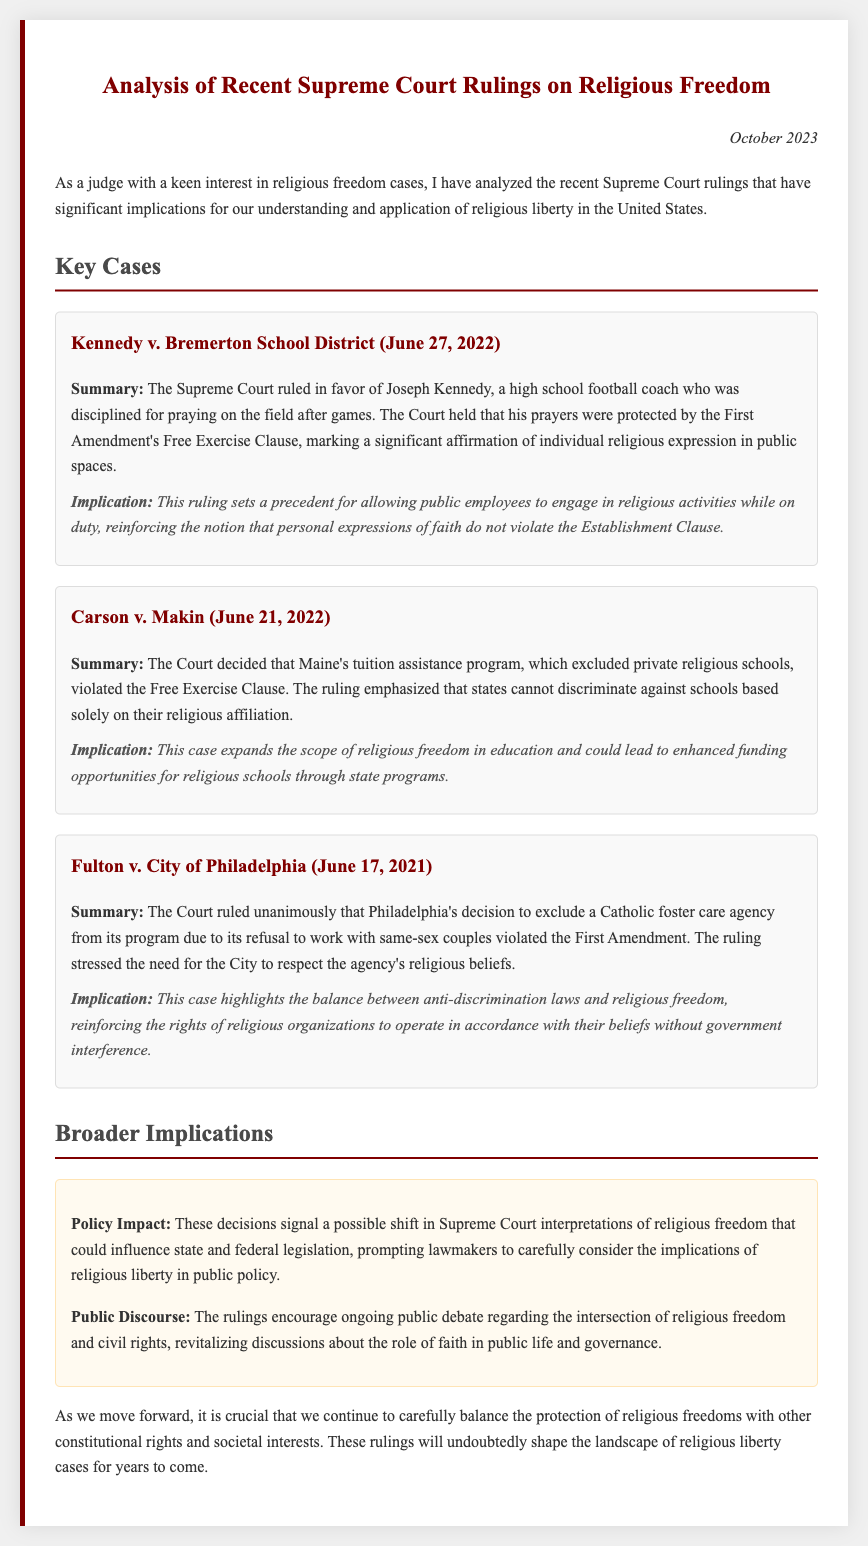What is the title of the memo? The title of the document summarizes its focus on Supreme Court rulings related to religious freedom.
Answer: Analysis of Recent Supreme Court Rulings on Religious Freedom When was the memo published? The publication date is noted in the document as a specific time frame for relevance.
Answer: October 2023 What is the outcome of the case Kennedy v. Bremerton School District? The document describes the ruling in favor of Joseph Kennedy regarding his right to pray on the field.
Answer: The Court ruled in favor of Joseph Kennedy What did the Court decide in Carson v. Makin? This question inquires about the specific ruling provided in the memo regarding Maine's tuition assistance program.
Answer: Violated the Free Exercise Clause In which case did the Court rule unanimously? The question seeks a specific case where the ruling had unanimous support, showing consensus among justices.
Answer: Fulton v. City of Philadelphia What is a key implication of the Kennedy case? This question focuses on the significance of the ruling concerning public employees' religious activities.
Answer: Personal expressions of faith do not violate the Establishment Clause What broader impact do the recent rulings suggest? This question looks for insights into potential shifts in legal interpretations of religious freedom affecting future policies.
Answer: Shift in Supreme Court interpretations of religious freedom What is the primary focus of the document? The question relates to the memo's overall purpose as indicated in the introduction.
Answer: Analysis of recent Supreme Court rulings on religious freedom 